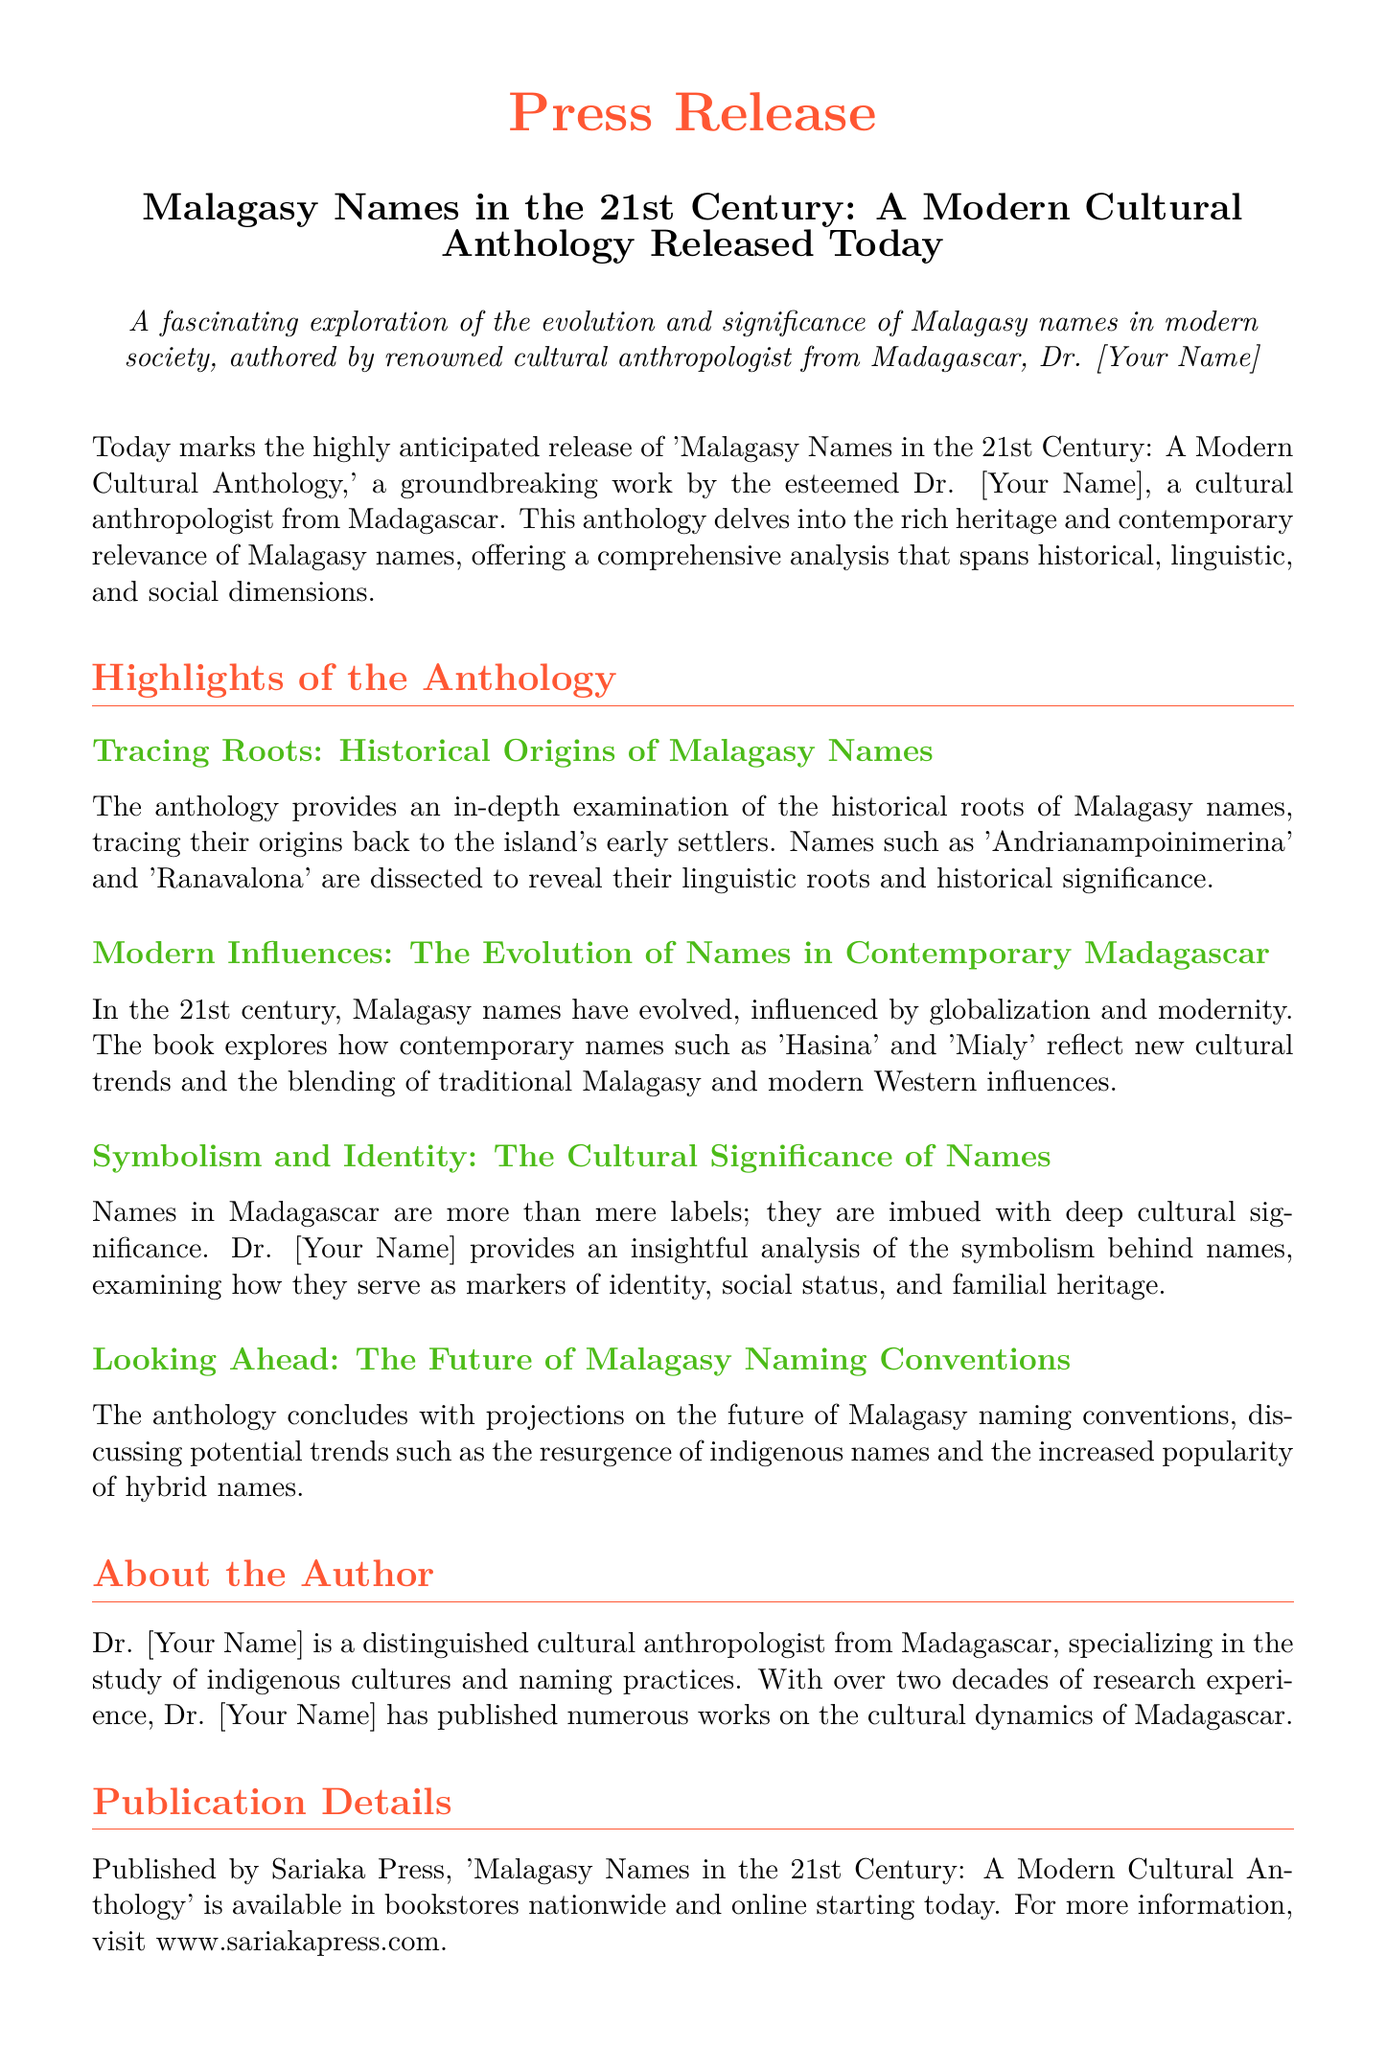What is the title of the anthology? The title of the anthology is stated in the press release as 'Malagasy Names in the 21st Century: A Modern Cultural Anthology.'
Answer: 'Malagasy Names in the 21st Century: A Modern Cultural Anthology' Who is the author of the anthology? The press release identifies the author as Dr. [Your Name], a cultural anthropologist from Madagascar.
Answer: Dr. [Your Name] What is the name of the publishing house? The publication details in the press release mention that the book is published by Sariaka Press.
Answer: Sariaka Press What is the main theme of the anthology? The press release describes the main theme as an exploration of the evolution and significance of Malagasy names in modern society.
Answer: Evolution and significance of Malagasy names What is one of the historical names examined in the anthology? The document lists 'Andrianampoinimerina' as one of the historical names examined in the anthology.
Answer: Andrianampoinimerina What are two contemporary names mentioned? The anthology discusses contemporary names such as 'Hasina' and 'Mialy.'
Answer: Hasina and Mialy What cultural elements does the anthology analyze in relation to names? The anthology analyzes the symbolism behind names, emphasizing identity, social status, and familial heritage as cultural elements.
Answer: Symbolism, identity, social status, familial heritage What future trend does the anthology predict? The press release mentions the prediction of a resurgence of indigenous names as a future trend in Malagasy naming conventions.
Answer: Resurgence of indigenous names 